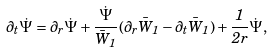<formula> <loc_0><loc_0><loc_500><loc_500>\partial _ { t } \dot { \Psi } = \partial _ { r } \dot { \Psi } + \frac { \dot { \Psi } } { \bar { W } _ { 1 } } ( \partial _ { r } \bar { W } _ { 1 } - \partial _ { t } \bar { W } _ { 1 } ) + \frac { 1 } { 2 r } \dot { \Psi } ,</formula> 